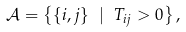Convert formula to latex. <formula><loc_0><loc_0><loc_500><loc_500>\mathcal { A } = \left \{ \{ i , j \} \ | \ T _ { i j } > 0 \right \} ,</formula> 